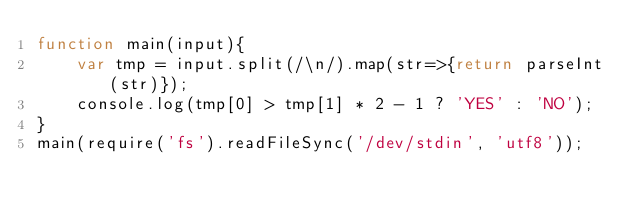Convert code to text. <code><loc_0><loc_0><loc_500><loc_500><_JavaScript_>function main(input){
    var tmp = input.split(/\n/).map(str=>{return parseInt(str)});
    console.log(tmp[0] > tmp[1] * 2 - 1 ? 'YES' : 'NO');
}
main(require('fs').readFileSync('/dev/stdin', 'utf8'));</code> 